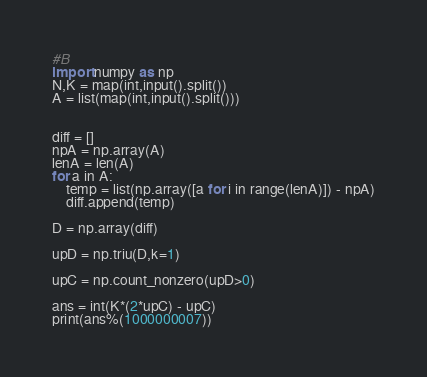Convert code to text. <code><loc_0><loc_0><loc_500><loc_500><_Python_>#B
import numpy as np
N,K = map(int,input().split())
A = list(map(int,input().split()))


diff = []
npA = np.array(A)
lenA = len(A)
for a in A:
    temp = list(np.array([a for i in range(lenA)]) - npA)
    diff.append(temp)

D = np.array(diff)

upD = np.triu(D,k=1)

upC = np.count_nonzero(upD>0)

ans = int(K*(2*upC) - upC)
print(ans%(1000000007))</code> 